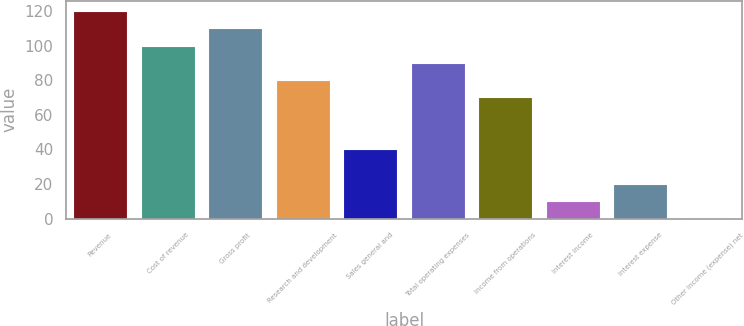Convert chart. <chart><loc_0><loc_0><loc_500><loc_500><bar_chart><fcel>Revenue<fcel>Cost of revenue<fcel>Gross profit<fcel>Research and development<fcel>Sales general and<fcel>Total operating expenses<fcel>Income from operations<fcel>Interest income<fcel>Interest expense<fcel>Other income (expense) net<nl><fcel>119.94<fcel>100<fcel>109.97<fcel>80.06<fcel>40.18<fcel>90.03<fcel>70.09<fcel>10.27<fcel>20.24<fcel>0.3<nl></chart> 